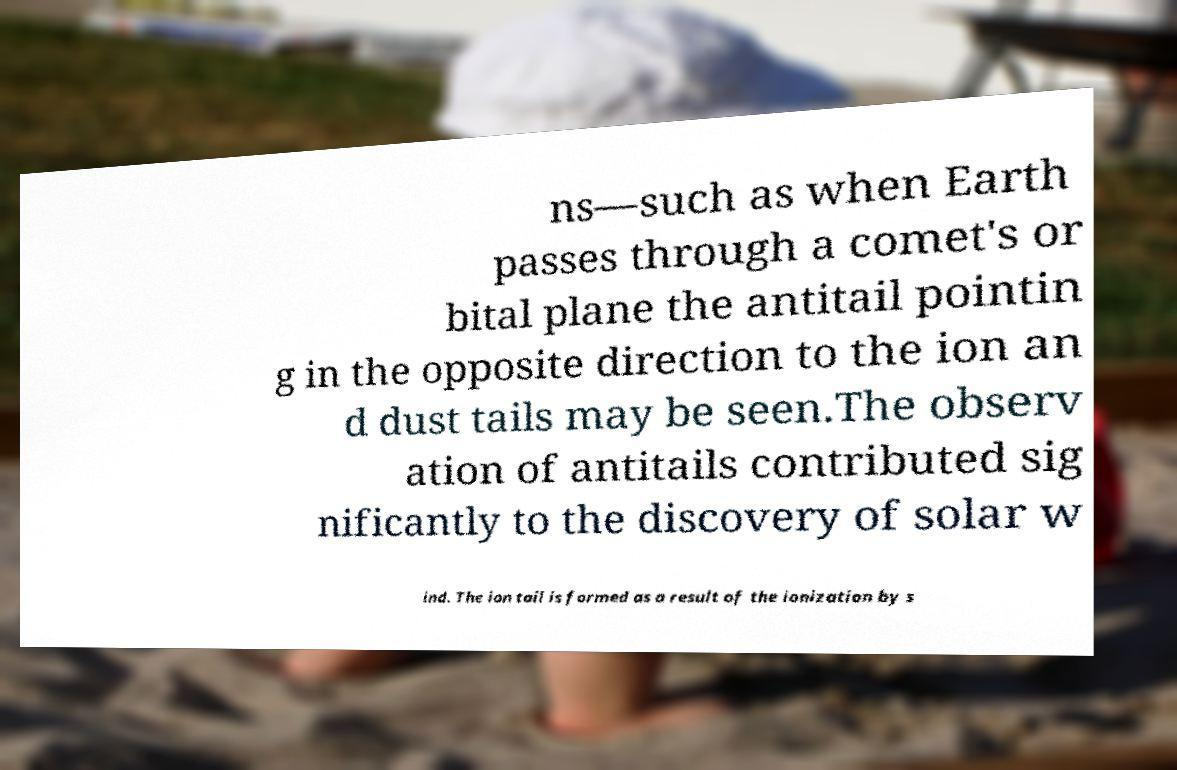There's text embedded in this image that I need extracted. Can you transcribe it verbatim? ns—such as when Earth passes through a comet's or bital plane the antitail pointin g in the opposite direction to the ion an d dust tails may be seen.The observ ation of antitails contributed sig nificantly to the discovery of solar w ind. The ion tail is formed as a result of the ionization by s 